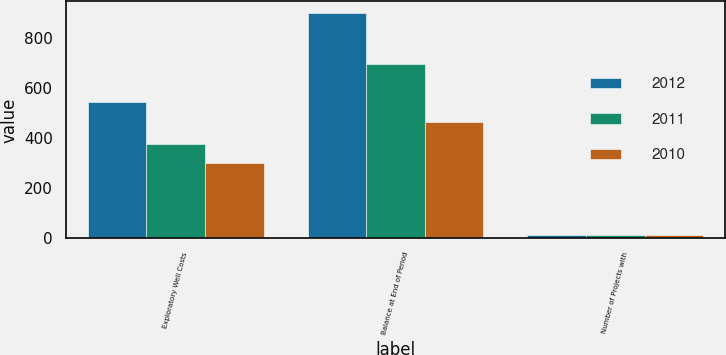Convert chart. <chart><loc_0><loc_0><loc_500><loc_500><stacked_bar_chart><ecel><fcel>Exploratory Well Costs<fcel>Balance at End of Period<fcel>Number of Projects with<nl><fcel>2012<fcel>545<fcel>900<fcel>14<nl><fcel>2011<fcel>378<fcel>696<fcel>13<nl><fcel>2010<fcel>300<fcel>466<fcel>13<nl></chart> 